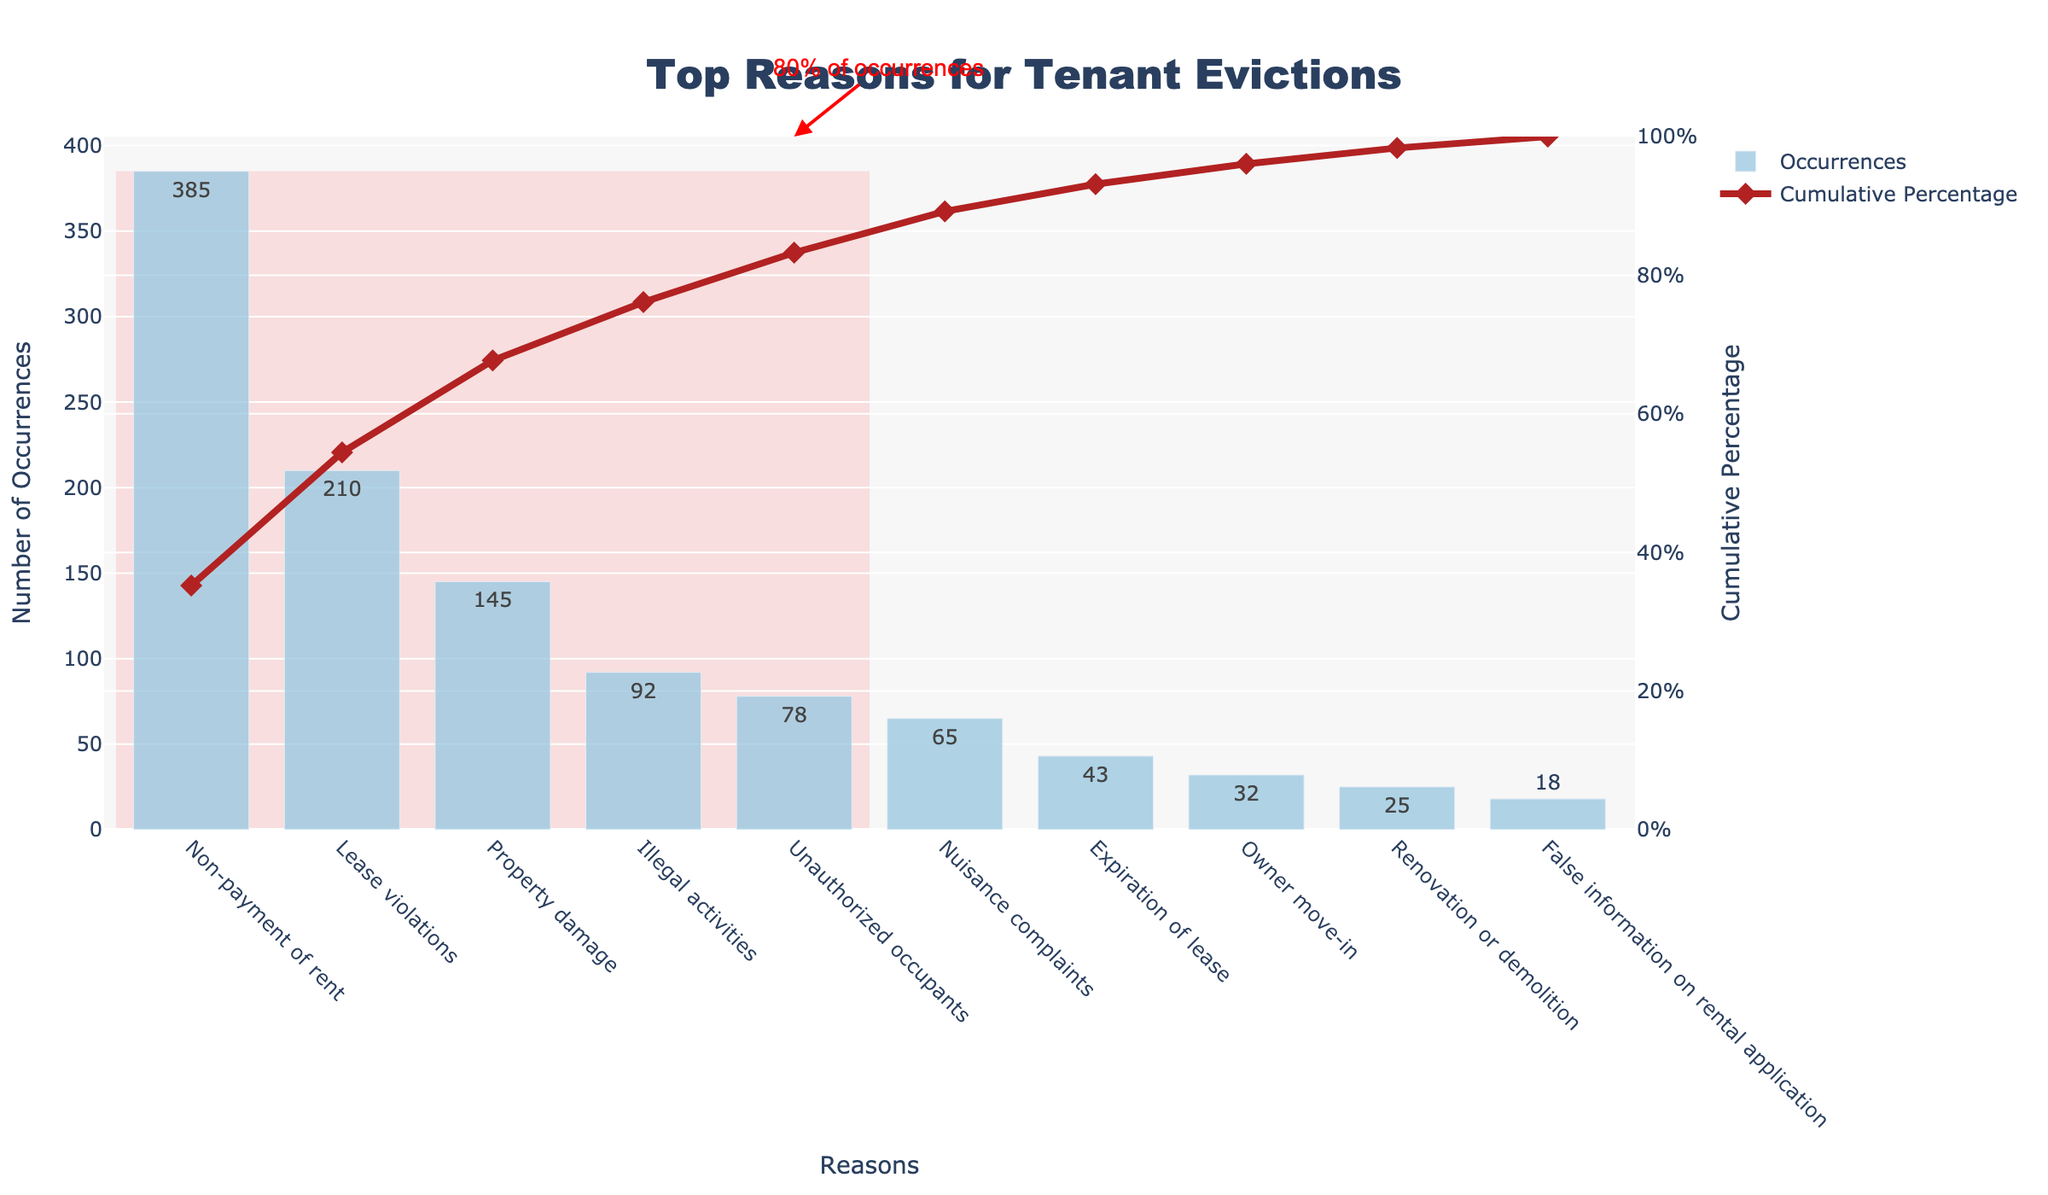What is the title of the figure? The title of a figure can usually be found at the top center of the plot. In this case, it is written in bold and reads "Top Reasons for Tenant Evictions."
Answer: Top Reasons for Tenant Evictions What is the reason with the highest number of occurrences? The Pareto chart shows the number of occurrences for each reason in descending order from left to right. The first bar represents the highest number of occurrences. Looking at the leftmost bar, the reason with the most occurrences is "Non-payment of rent," which has 385 occurrences shown in the bar and its label.
Answer: Non-payment of rent How many occurrences are listed for "Unauthorized occupants"? Locate "Unauthorized occupants" on the x-axis and look directly above to the corresponding bar. The number inside the bar shows the occurrences, which is 78.
Answer: 78 What percentage of the reasons is covered by the first three bars? Look at the cumulative percentage line (red dotted line) that follows the bars from left to right. The cumulative percentage at the third bar (representing "Property damage") is the value you need, which looks like roughly 57%. Finally, verify this with the numerical label, which indicates approximately 57%.
Answer: ~57% What is the total number of eviction occurrences visualized in the figure? Sum all the occurrences from each bar; that is 385 (Non-payment of rent) + 210 (Lease violations) + 145 (Property damage) + 92 (Illegal activities) + 78 (Unauthorized occupants) + 65 (Nuisance complaints) + 43 (Expiration of lease) + 32 (Owner move-in) + 25 (Renovation or demolition) + 18 (False information on rental application). This totals to 1093 occurrences.
Answer: 1093 Which category is contributing to reaching 80% of total occurrences in the cumulative percentage? The annotation in the figure shows "80% of occurrences" with an arrow pointing to the 4th bar. Counting from the left, the reason marked by the arrow is "Illegal activities."
Answer: Illegal activities What is the cumulative percentage after six reasons? The cumulative percentage can be acquired by looking at the red line where it intersects above the sixth bar. You observe the bar above "Nuisance complaints," and see approximately 89% shown on the secondary y-axis.
Answer: ~89% Which reason falls exactly at the middle of all listed reasons? With ten reasons listed, the middle reason falls at the 5th position (the list is sorted by occurrences). Locate the fifth bar from the left, which represents "Unauthorized occupants."
Answer: Unauthorized occupants 